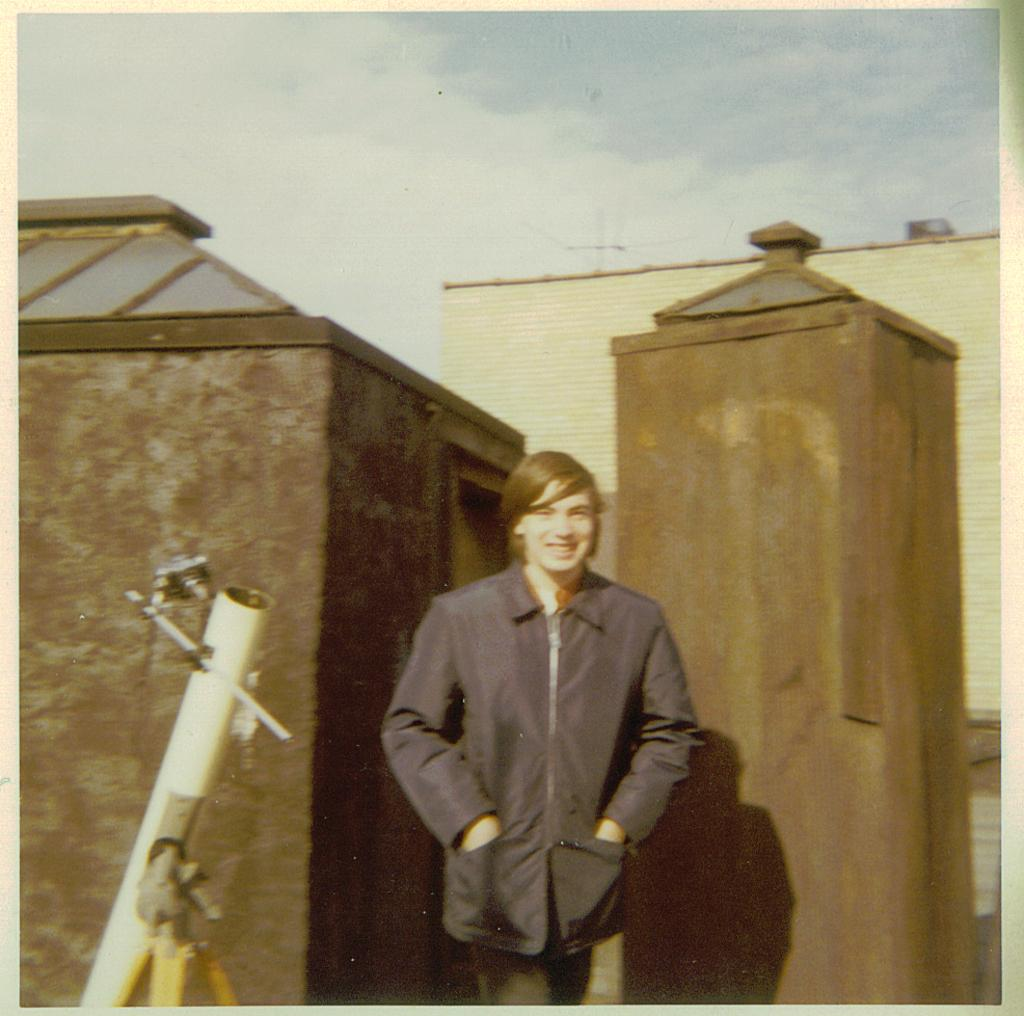What is the person in the image doing? The person is standing on top of a building and using a telescope. What can be seen behind the person? There are buildings behind the person. What type of stitch is the person using to sew the soda can in the image? There is no soda can or stitching activity present in the image. What type of beef dish is the person preparing in the image? There is no beef dish or cooking activity present in the image. 